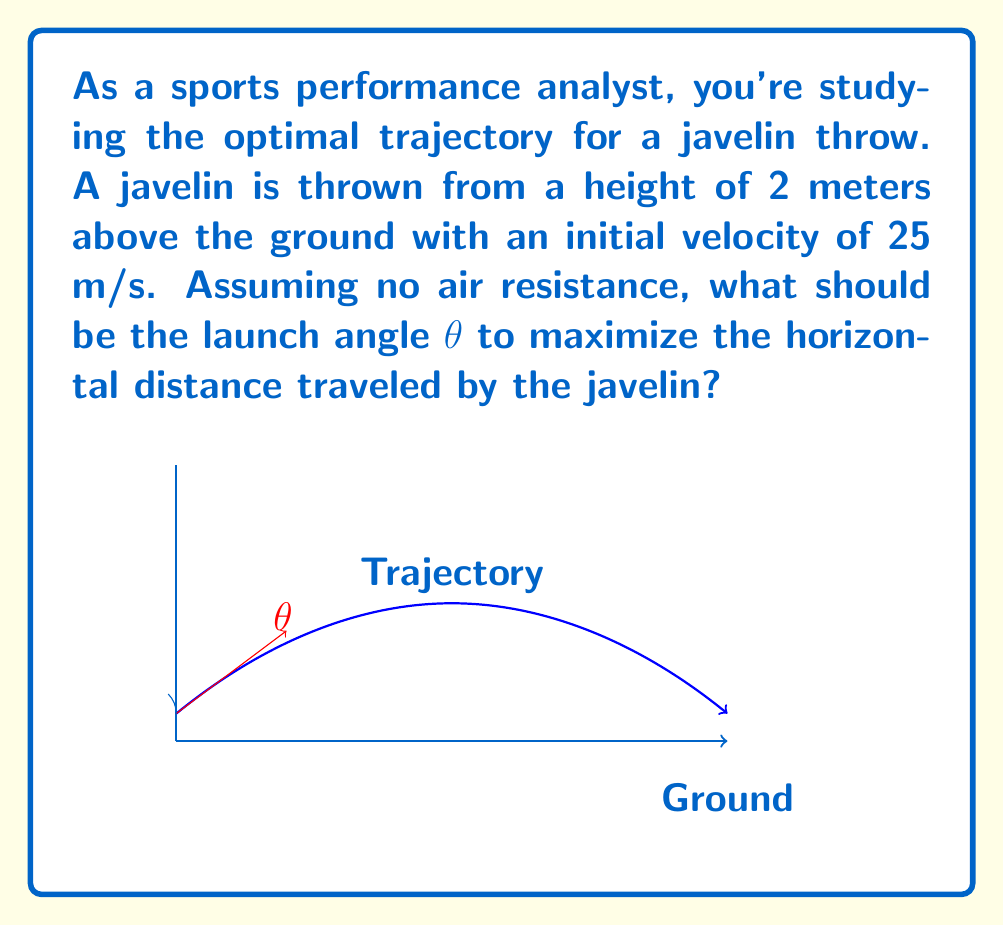Show me your answer to this math problem. To solve this problem, we'll use the equations of projectile motion and optimize for maximum range. Let's break it down step-by-step:

1) The range (R) of a projectile launched from height h₀ with initial velocity v₀ at angle θ is given by:

   $$R = \frac{v_0 \cos \theta}{g} \left(v_0 \sin \theta + \sqrt{(v_0 \sin \theta)^2 + 2gh_0}\right)$$

   where g is the acceleration due to gravity (9.8 m/s²).

2) To find the optimal angle, we need to maximize R with respect to θ. We can do this by differentiating R with respect to θ and setting it to zero:

   $$\frac{dR}{d\theta} = 0$$

3) After differentiation and simplification, we get:

   $$\tan \theta = \frac{1}{2} \left(\frac{v_0^2}{gh_0} + \sqrt{\left(\frac{v_0^2}{gh_0}\right)^2 + 4}\right)$$

4) Substituting the given values: v₀ = 25 m/s, h₀ = 2 m, g = 9.8 m/s²:

   $$\tan \theta = \frac{1}{2} \left(\frac{25^2}{9.8 \cdot 2} + \sqrt{\left(\frac{25^2}{9.8 \cdot 2}\right)^2 + 4}\right)$$

5) Solving this equation:

   $$\tan \theta = 0.9125$$

6) Taking the inverse tangent:

   $$\theta = \arctan(0.9125) \approx 42.3^\circ$$

This angle maximizes the horizontal distance traveled by the javelin under the given conditions.
Answer: $42.3^\circ$ 